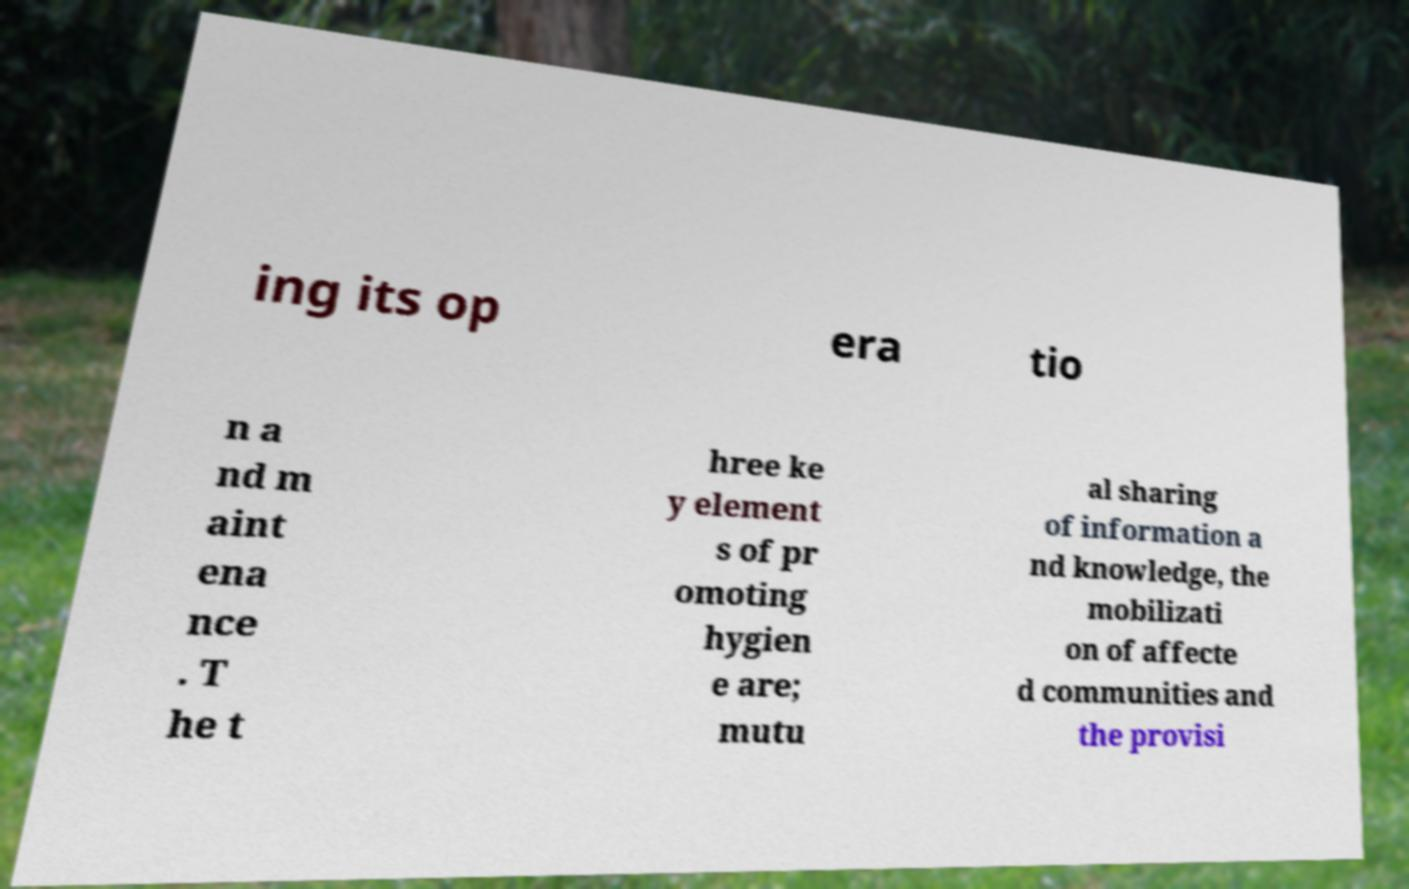Can you read and provide the text displayed in the image?This photo seems to have some interesting text. Can you extract and type it out for me? ing its op era tio n a nd m aint ena nce . T he t hree ke y element s of pr omoting hygien e are; mutu al sharing of information a nd knowledge, the mobilizati on of affecte d communities and the provisi 